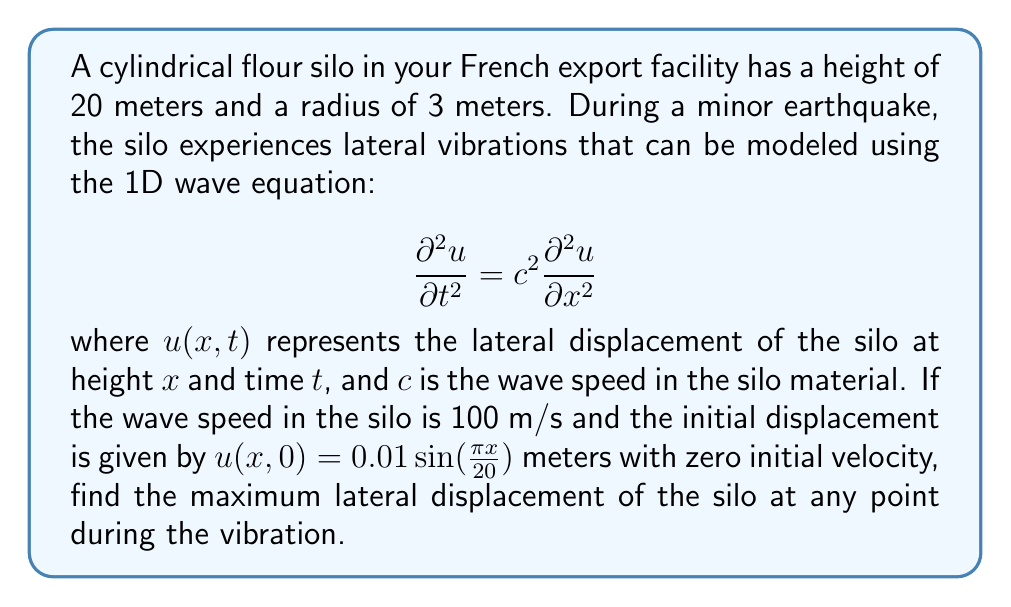Show me your answer to this math problem. To solve this problem, we'll follow these steps:

1) The general solution to the 1D wave equation with fixed ends (as in a silo fixed at the bottom and free at the top) is:

   $$u(x,t) = \sum_{n=1}^{\infty} (A_n \cos(\omega_n t) + B_n \sin(\omega_n t)) \sin(\frac{n\pi x}{L})$$

   where $L$ is the length (height) of the silo, and $\omega_n = \frac{n\pi c}{L}$.

2) Given the initial condition $u(x,0) = 0.01 \sin(\frac{\pi x}{20})$, we can see that only the first mode ($n=1$) is excited, and $A_1 = 0.01$, $B_1 = 0$.

3) The zero initial velocity condition is already satisfied by this solution.

4) Therefore, our specific solution is:

   $$u(x,t) = 0.01 \cos(\omega_1 t) \sin(\frac{\pi x}{20})$$

5) We need to calculate $\omega_1$:

   $$\omega_1 = \frac{\pi c}{L} = \frac{\pi \cdot 100}{20} = 5\pi$$

6) So our final solution is:

   $$u(x,t) = 0.01 \cos(5\pi t) \sin(\frac{\pi x}{20})$$

7) The maximum displacement occurs when $\cos(5\pi t) = \pm 1$ and $\sin(\frac{\pi x}{20})$ is at its maximum value of 1.

8) Therefore, the maximum displacement is 0.01 meters or 1 cm.
Answer: 0.01 meters 